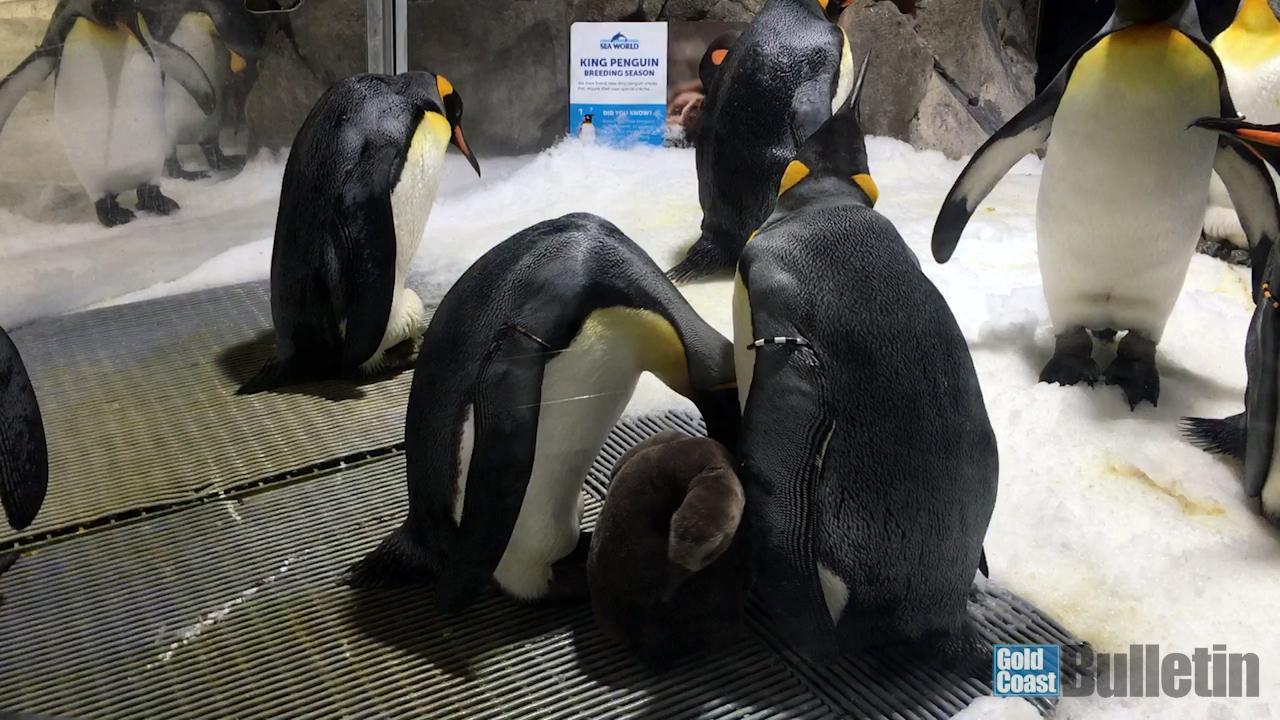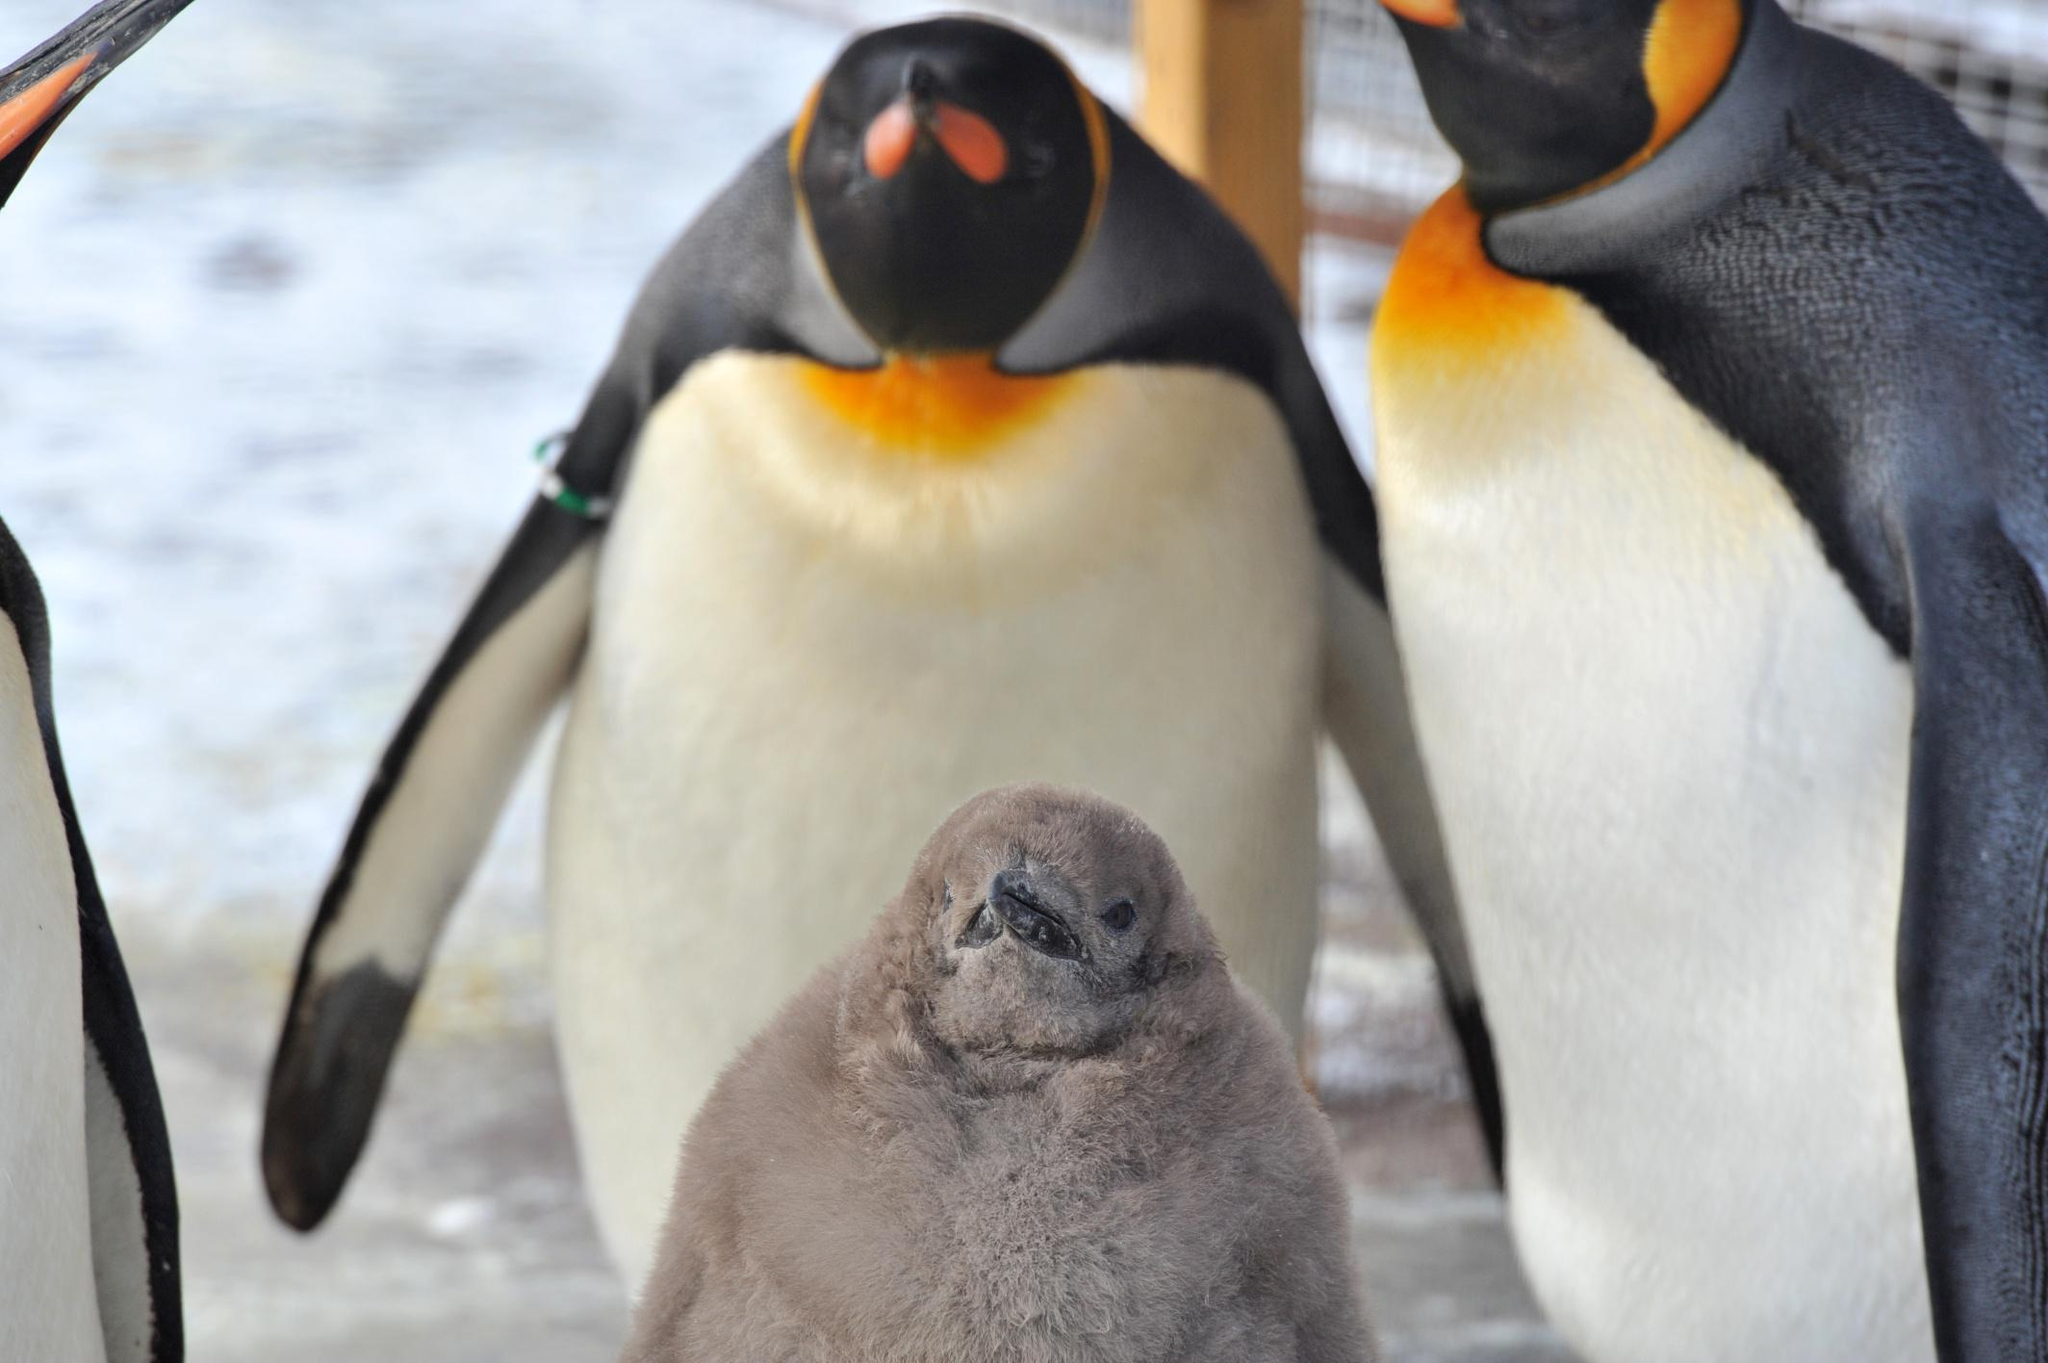The first image is the image on the left, the second image is the image on the right. Evaluate the accuracy of this statement regarding the images: "We can see exactly two baby penguins.". Is it true? Answer yes or no. Yes. The first image is the image on the left, the second image is the image on the right. For the images displayed, is the sentence "Both photos in the pair have adult penguins and young penguins." factually correct? Answer yes or no. Yes. 